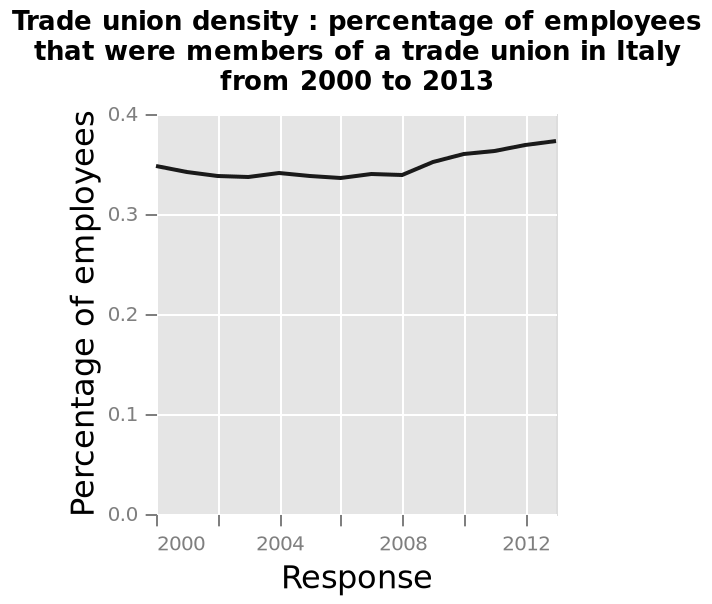<image>
please describe the details of the chart Trade union density : percentage of employees that were members of a trade union in Italy from 2000 to 2013 is a line chart. The x-axis plots Response while the y-axis measures Percentage of employees. please summary the statistics and relations of the chart The graph shows that over 13 years the amount of Italians who belong to a trade union havent been that varied. The lowest was between 2006 and 2008 but then started to increase. 2012 and 2013 had the most trade union members. 